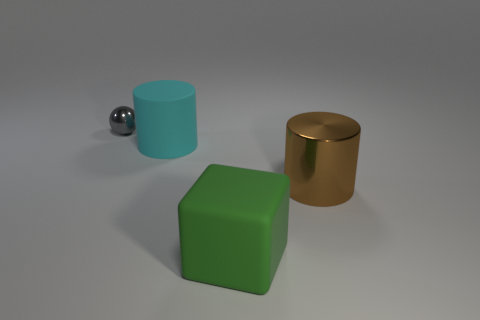There is a object that is in front of the metal thing that is right of the cyan thing; are there any cyan cylinders right of it?
Offer a terse response. No. What is the shape of the shiny thing that is the same size as the green cube?
Offer a terse response. Cylinder. Are there any large metallic cylinders of the same color as the big block?
Offer a very short reply. No. Is the shape of the gray shiny object the same as the green thing?
Ensure brevity in your answer.  No. How many small objects are either yellow metallic blocks or gray spheres?
Your response must be concise. 1. There is a thing that is made of the same material as the ball; what is its color?
Offer a terse response. Brown. How many tiny spheres are the same material as the block?
Offer a very short reply. 0. There is a matte thing that is in front of the large metal cylinder; is its size the same as the metallic thing that is to the left of the big green thing?
Give a very brief answer. No. The large cylinder behind the large cylinder that is right of the matte cube is made of what material?
Provide a succinct answer. Rubber. Are there fewer rubber things that are to the left of the sphere than cylinders that are in front of the big cyan object?
Give a very brief answer. Yes. 